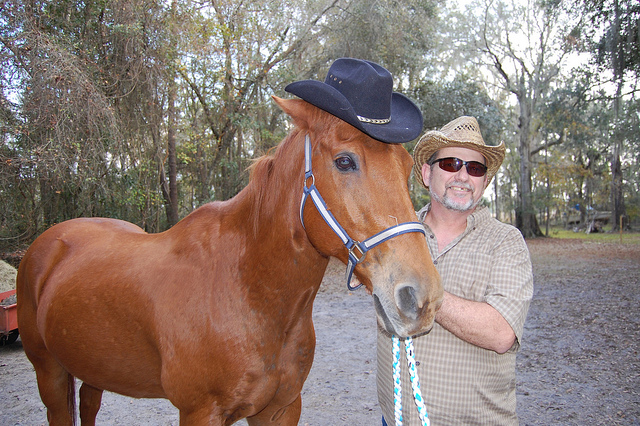<image>Are they friends? I don't know if they are friends. Are they friends? It is ambiguous whether they are friends or not. 